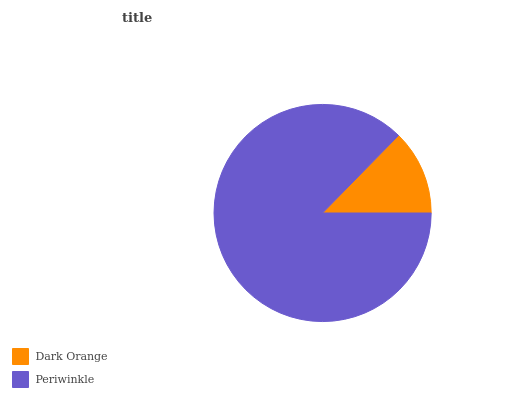Is Dark Orange the minimum?
Answer yes or no. Yes. Is Periwinkle the maximum?
Answer yes or no. Yes. Is Periwinkle the minimum?
Answer yes or no. No. Is Periwinkle greater than Dark Orange?
Answer yes or no. Yes. Is Dark Orange less than Periwinkle?
Answer yes or no. Yes. Is Dark Orange greater than Periwinkle?
Answer yes or no. No. Is Periwinkle less than Dark Orange?
Answer yes or no. No. Is Periwinkle the high median?
Answer yes or no. Yes. Is Dark Orange the low median?
Answer yes or no. Yes. Is Dark Orange the high median?
Answer yes or no. No. Is Periwinkle the low median?
Answer yes or no. No. 